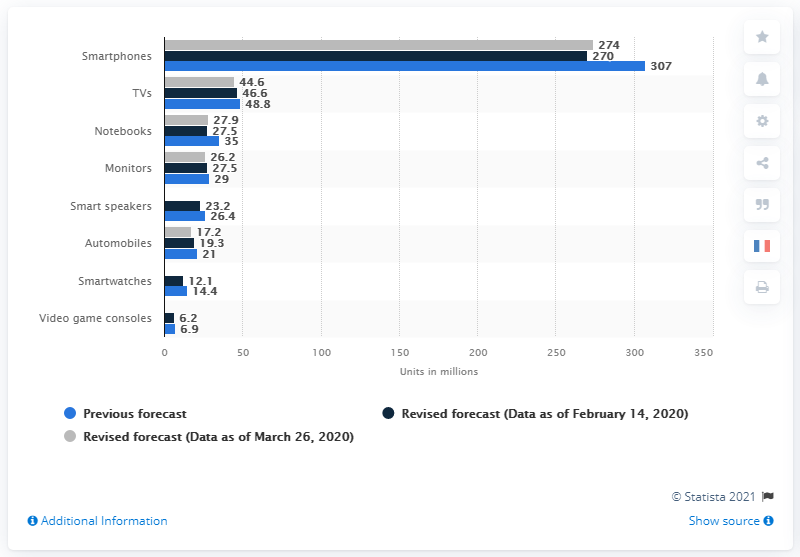Outline some significant characteristics in this image. The previous forecast for notebook shipments in the first quarter of 2020 was 35. In the first quarter of 2020, global notebook shipments were 27.9 million. 